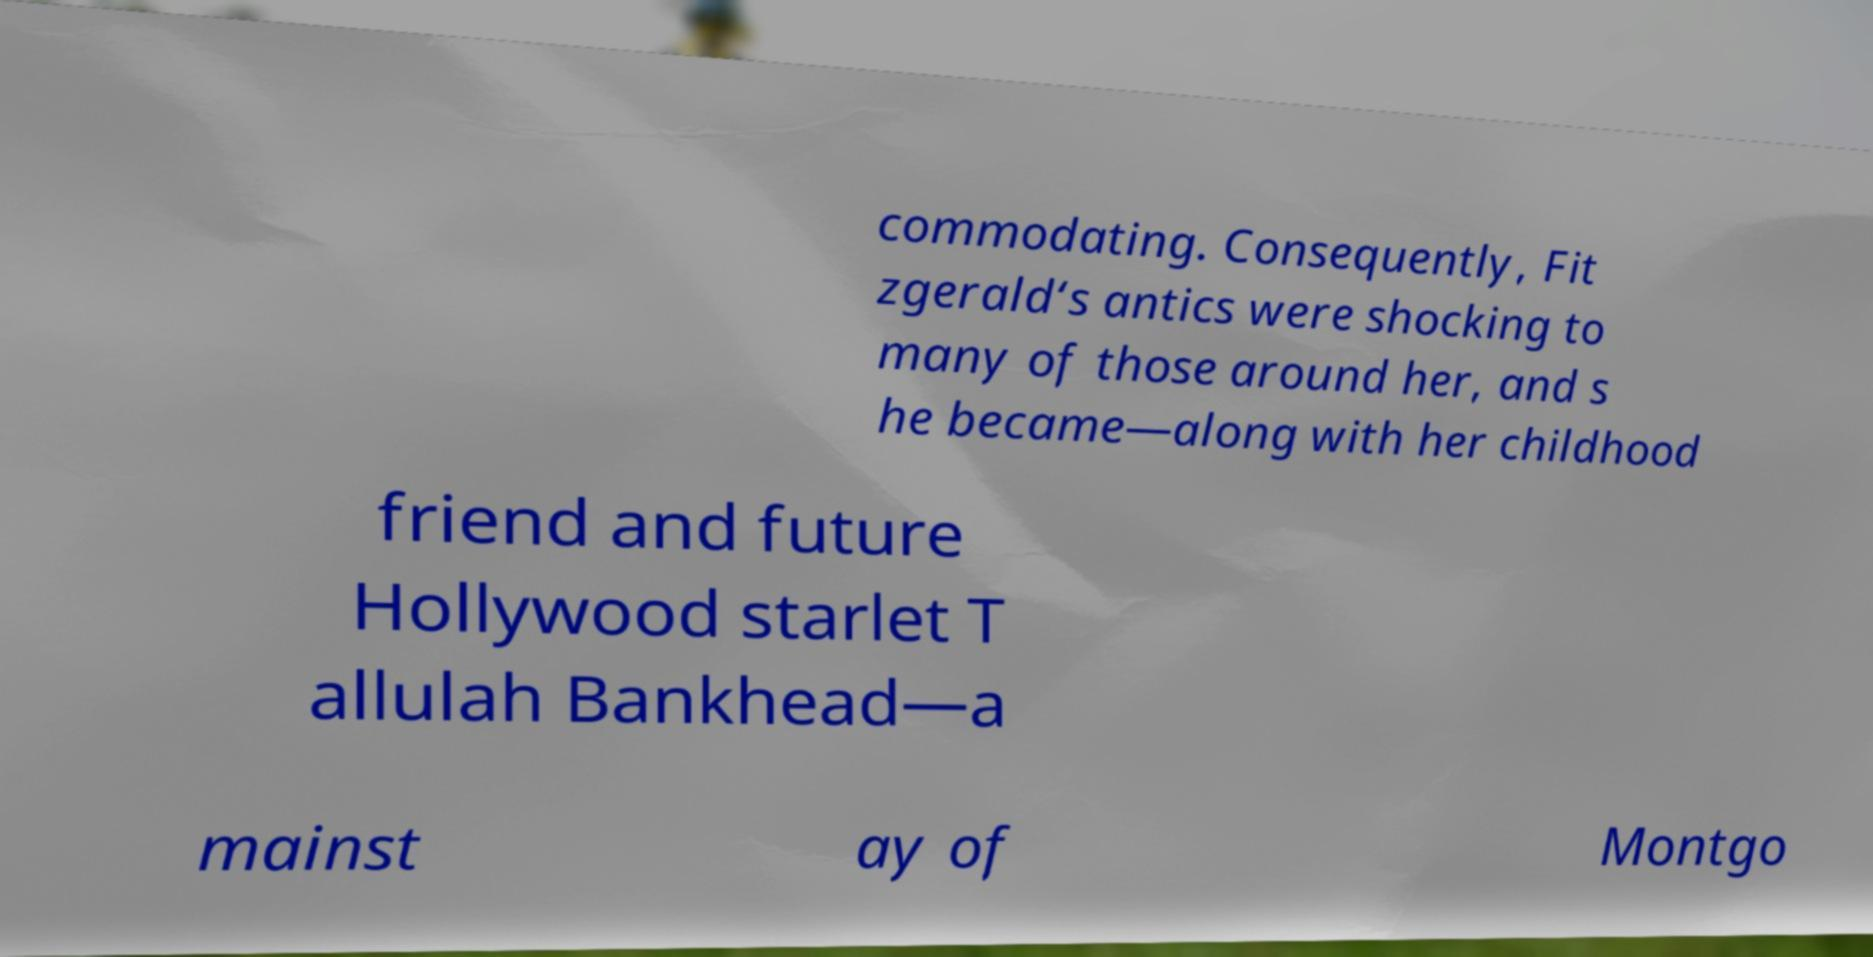There's text embedded in this image that I need extracted. Can you transcribe it verbatim? commodating. Consequently, Fit zgerald‘s antics were shocking to many of those around her, and s he became—along with her childhood friend and future Hollywood starlet T allulah Bankhead—a mainst ay of Montgo 